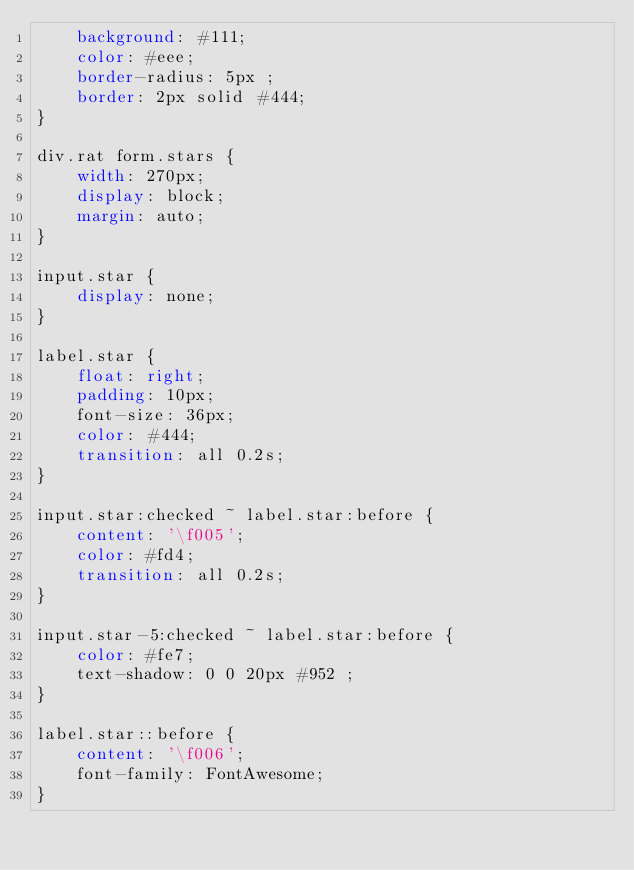<code> <loc_0><loc_0><loc_500><loc_500><_CSS_>    background: #111;
    color: #eee;
    border-radius: 5px ;
    border: 2px solid #444;
}

div.rat form.stars {
    width: 270px;
    display: block;
    margin: auto;
}

input.star {
    display: none;
}

label.star {
    float: right;
    padding: 10px;
    font-size: 36px;
    color: #444;
    transition: all 0.2s;
}

input.star:checked ~ label.star:before {
    content: '\f005';
    color: #fd4;
    transition: all 0.2s;
}

input.star-5:checked ~ label.star:before {
    color: #fe7;
    text-shadow: 0 0 20px #952 ;
}

label.star::before {
    content: '\f006';
    font-family: FontAwesome;
}</code> 